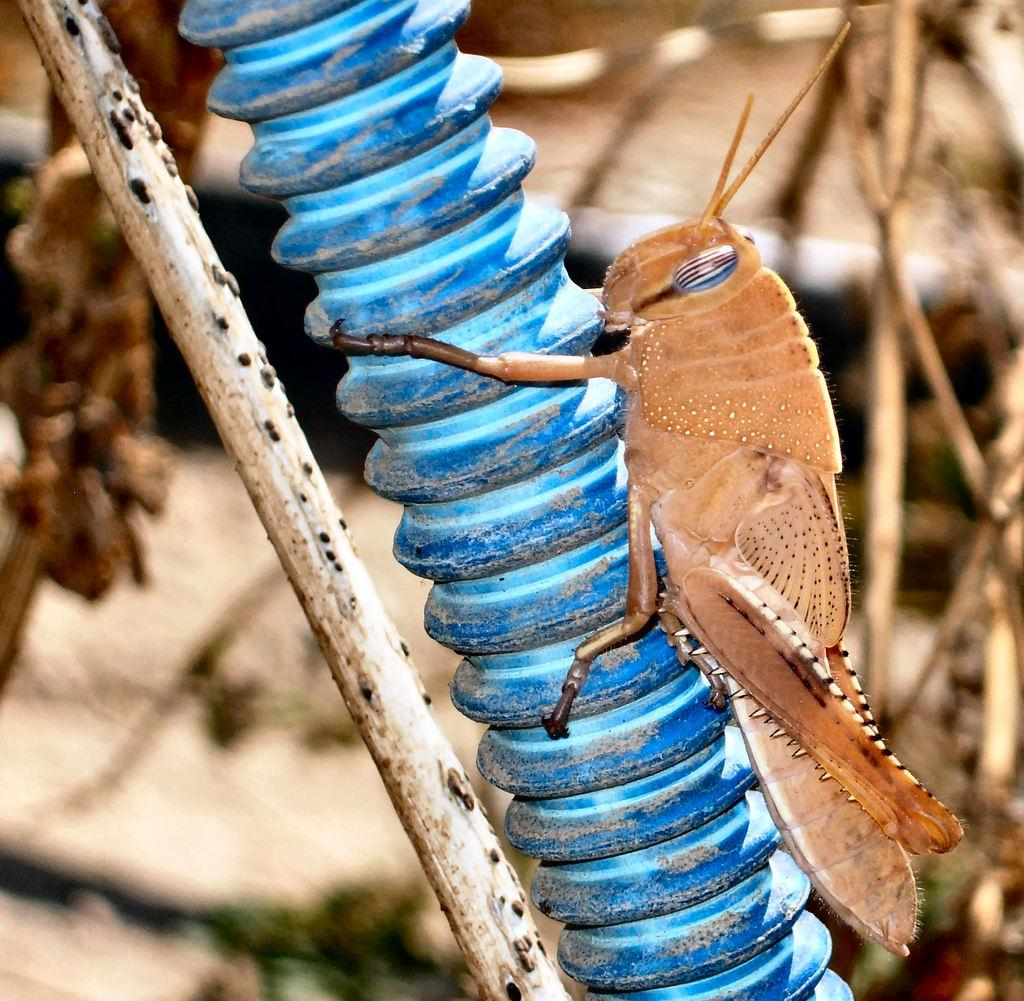What is the main subject of the image? There is a grasshopper on a pipe in the image. What can be seen towards the left side of the image? There is a stick visible towards the left side of the image. How would you describe the background of the image? The background of the image is blurred. What type of natural elements can be seen in the background? There are twigs visible in the background of the image. What type of crown is the clam wearing in the image? There is no clam or crown present in the image. Where can the stamp be found in the image? There is no stamp present in the image. 